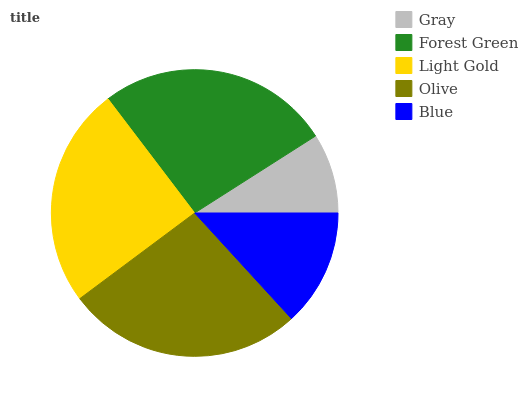Is Gray the minimum?
Answer yes or no. Yes. Is Olive the maximum?
Answer yes or no. Yes. Is Forest Green the minimum?
Answer yes or no. No. Is Forest Green the maximum?
Answer yes or no. No. Is Forest Green greater than Gray?
Answer yes or no. Yes. Is Gray less than Forest Green?
Answer yes or no. Yes. Is Gray greater than Forest Green?
Answer yes or no. No. Is Forest Green less than Gray?
Answer yes or no. No. Is Light Gold the high median?
Answer yes or no. Yes. Is Light Gold the low median?
Answer yes or no. Yes. Is Blue the high median?
Answer yes or no. No. Is Olive the low median?
Answer yes or no. No. 